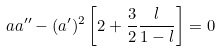Convert formula to latex. <formula><loc_0><loc_0><loc_500><loc_500>a a ^ { \prime \prime } - ( a ^ { \prime } ) ^ { 2 } \left [ 2 + \frac { 3 } { 2 } \frac { l } { 1 - l } \right ] = 0</formula> 